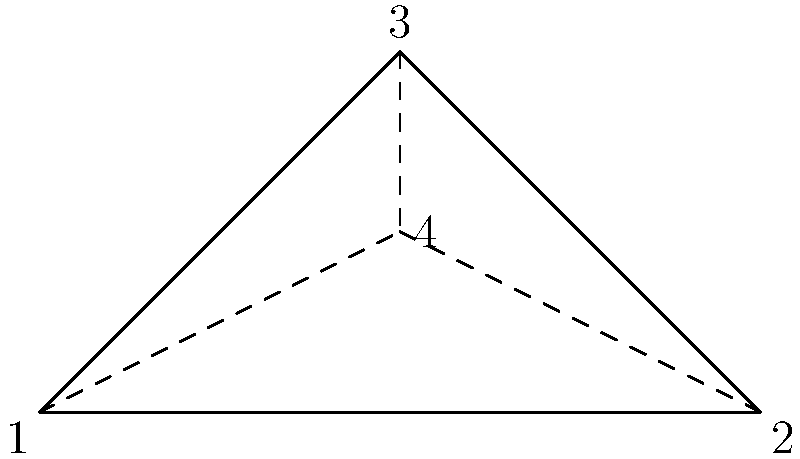Consider the fisherman's knot shown in the diagram, which is commonly used to join two ropes. The knot has three outer points (1, 2, and 3) and one central point (4). What is the order of the symmetry group of this knot? To determine the order of the symmetry group, we need to count the number of symmetry operations that leave the knot unchanged:

1. Identity: The knot remains unchanged (always counts as one symmetry).

2. Rotations: 
   - 120° clockwise rotation
   - 240° clockwise rotation (equivalent to 120° counterclockwise)

3. Reflections:
   - Reflection across the line from point 1 to point 4
   - Reflection across the line from point 2 to point 4
   - Reflection across the line from point 3 to point 4

In total, we have 1 (identity) + 2 (rotations) + 3 (reflections) = 6 symmetry operations.

The order of a group is the number of elements in the group. Since each symmetry operation corresponds to an element in the symmetry group, the order of the symmetry group is 6.

This group is isomorphic to $D_3$, the dihedral group of order 6, which is the symmetry group of an equilateral triangle.
Answer: 6 